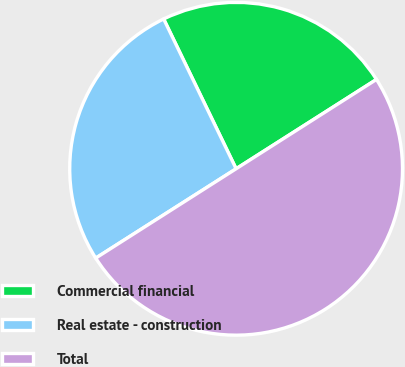Convert chart. <chart><loc_0><loc_0><loc_500><loc_500><pie_chart><fcel>Commercial financial<fcel>Real estate - construction<fcel>Total<nl><fcel>23.15%<fcel>26.85%<fcel>50.0%<nl></chart> 